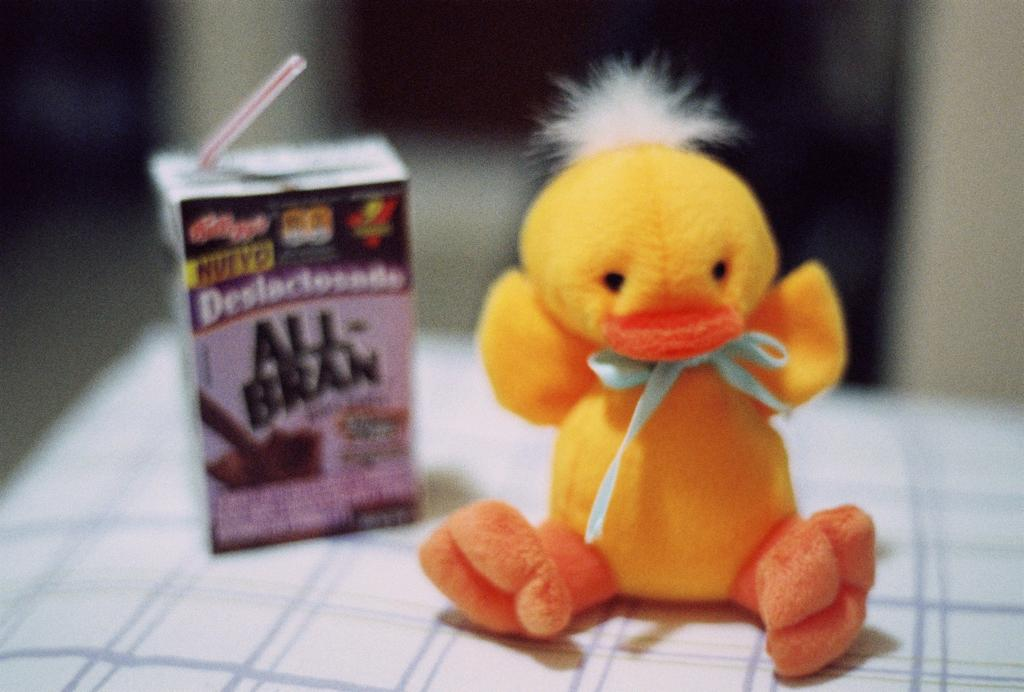What object is on the table in the image? There is a toy on the table. What else is on the table in the image? There is a carton on the table. What can be seen in the background of the image? There is a wall in the background of the image. What is the aftermath of the loud noise heard in the image? There is no loud noise or aftermath mentioned in the image, as it only features a toy, a carton, and a wall in the background. 